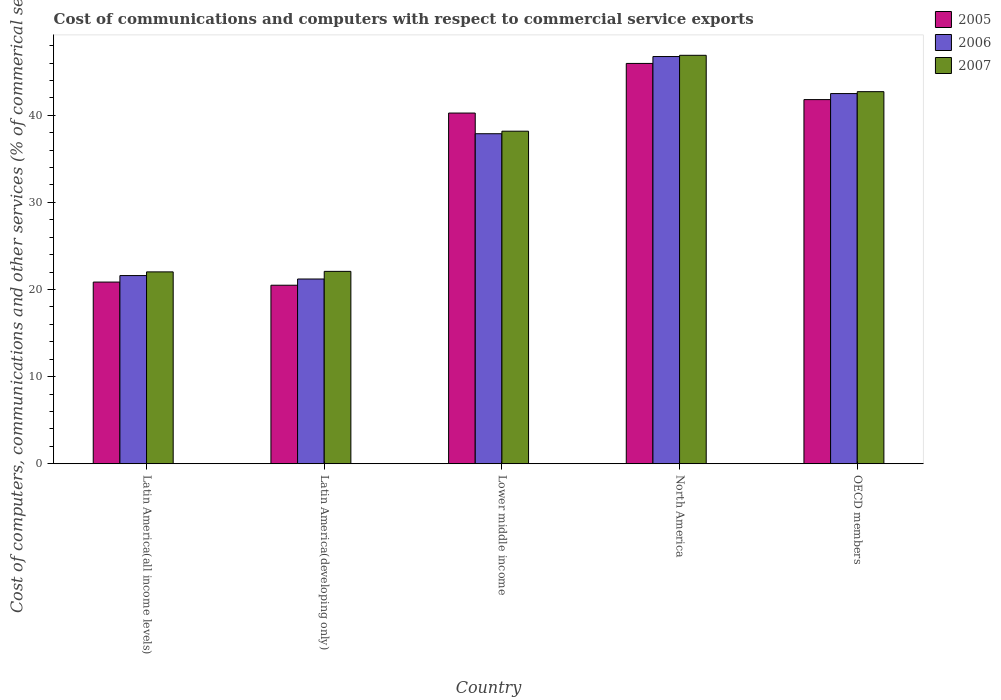How many bars are there on the 2nd tick from the left?
Your answer should be compact. 3. How many bars are there on the 5th tick from the right?
Make the answer very short. 3. What is the label of the 2nd group of bars from the left?
Your response must be concise. Latin America(developing only). What is the cost of communications and computers in 2005 in Latin America(developing only)?
Your answer should be very brief. 20.49. Across all countries, what is the maximum cost of communications and computers in 2006?
Your response must be concise. 46.75. Across all countries, what is the minimum cost of communications and computers in 2005?
Provide a short and direct response. 20.49. In which country was the cost of communications and computers in 2006 minimum?
Offer a terse response. Latin America(developing only). What is the total cost of communications and computers in 2007 in the graph?
Your response must be concise. 171.89. What is the difference between the cost of communications and computers in 2005 in Latin America(all income levels) and that in OECD members?
Keep it short and to the point. -20.95. What is the difference between the cost of communications and computers in 2007 in North America and the cost of communications and computers in 2006 in OECD members?
Give a very brief answer. 4.39. What is the average cost of communications and computers in 2006 per country?
Provide a short and direct response. 33.99. What is the difference between the cost of communications and computers of/in 2005 and cost of communications and computers of/in 2007 in Latin America(all income levels)?
Give a very brief answer. -1.17. What is the ratio of the cost of communications and computers in 2005 in Latin America(all income levels) to that in North America?
Your answer should be very brief. 0.45. Is the cost of communications and computers in 2007 in Latin America(developing only) less than that in OECD members?
Provide a short and direct response. Yes. What is the difference between the highest and the second highest cost of communications and computers in 2006?
Make the answer very short. 4.61. What is the difference between the highest and the lowest cost of communications and computers in 2005?
Your answer should be compact. 25.46. Is the sum of the cost of communications and computers in 2005 in Lower middle income and North America greater than the maximum cost of communications and computers in 2007 across all countries?
Offer a very short reply. Yes. What does the 1st bar from the right in OECD members represents?
Your answer should be compact. 2007. How many bars are there?
Provide a succinct answer. 15. Does the graph contain any zero values?
Offer a terse response. No. Where does the legend appear in the graph?
Ensure brevity in your answer.  Top right. How many legend labels are there?
Your response must be concise. 3. What is the title of the graph?
Offer a terse response. Cost of communications and computers with respect to commercial service exports. Does "1994" appear as one of the legend labels in the graph?
Your answer should be compact. No. What is the label or title of the Y-axis?
Provide a succinct answer. Cost of computers, communications and other services (% of commerical service exports). What is the Cost of computers, communications and other services (% of commerical service exports) of 2005 in Latin America(all income levels)?
Ensure brevity in your answer.  20.86. What is the Cost of computers, communications and other services (% of commerical service exports) of 2006 in Latin America(all income levels)?
Your answer should be compact. 21.6. What is the Cost of computers, communications and other services (% of commerical service exports) of 2007 in Latin America(all income levels)?
Your answer should be compact. 22.02. What is the Cost of computers, communications and other services (% of commerical service exports) in 2005 in Latin America(developing only)?
Give a very brief answer. 20.49. What is the Cost of computers, communications and other services (% of commerical service exports) of 2006 in Latin America(developing only)?
Your answer should be compact. 21.21. What is the Cost of computers, communications and other services (% of commerical service exports) of 2007 in Latin America(developing only)?
Keep it short and to the point. 22.09. What is the Cost of computers, communications and other services (% of commerical service exports) in 2005 in Lower middle income?
Keep it short and to the point. 40.26. What is the Cost of computers, communications and other services (% of commerical service exports) in 2006 in Lower middle income?
Provide a succinct answer. 37.89. What is the Cost of computers, communications and other services (% of commerical service exports) in 2007 in Lower middle income?
Provide a short and direct response. 38.18. What is the Cost of computers, communications and other services (% of commerical service exports) in 2005 in North America?
Make the answer very short. 45.96. What is the Cost of computers, communications and other services (% of commerical service exports) in 2006 in North America?
Your response must be concise. 46.75. What is the Cost of computers, communications and other services (% of commerical service exports) of 2007 in North America?
Provide a short and direct response. 46.89. What is the Cost of computers, communications and other services (% of commerical service exports) of 2005 in OECD members?
Give a very brief answer. 41.8. What is the Cost of computers, communications and other services (% of commerical service exports) in 2006 in OECD members?
Give a very brief answer. 42.5. What is the Cost of computers, communications and other services (% of commerical service exports) in 2007 in OECD members?
Your answer should be very brief. 42.72. Across all countries, what is the maximum Cost of computers, communications and other services (% of commerical service exports) of 2005?
Give a very brief answer. 45.96. Across all countries, what is the maximum Cost of computers, communications and other services (% of commerical service exports) in 2006?
Your response must be concise. 46.75. Across all countries, what is the maximum Cost of computers, communications and other services (% of commerical service exports) of 2007?
Make the answer very short. 46.89. Across all countries, what is the minimum Cost of computers, communications and other services (% of commerical service exports) in 2005?
Your answer should be compact. 20.49. Across all countries, what is the minimum Cost of computers, communications and other services (% of commerical service exports) in 2006?
Your response must be concise. 21.21. Across all countries, what is the minimum Cost of computers, communications and other services (% of commerical service exports) in 2007?
Your answer should be compact. 22.02. What is the total Cost of computers, communications and other services (% of commerical service exports) in 2005 in the graph?
Give a very brief answer. 169.37. What is the total Cost of computers, communications and other services (% of commerical service exports) of 2006 in the graph?
Your response must be concise. 169.94. What is the total Cost of computers, communications and other services (% of commerical service exports) of 2007 in the graph?
Provide a succinct answer. 171.89. What is the difference between the Cost of computers, communications and other services (% of commerical service exports) in 2005 in Latin America(all income levels) and that in Latin America(developing only)?
Give a very brief answer. 0.36. What is the difference between the Cost of computers, communications and other services (% of commerical service exports) of 2006 in Latin America(all income levels) and that in Latin America(developing only)?
Keep it short and to the point. 0.4. What is the difference between the Cost of computers, communications and other services (% of commerical service exports) in 2007 in Latin America(all income levels) and that in Latin America(developing only)?
Offer a very short reply. -0.06. What is the difference between the Cost of computers, communications and other services (% of commerical service exports) of 2005 in Latin America(all income levels) and that in Lower middle income?
Your answer should be compact. -19.4. What is the difference between the Cost of computers, communications and other services (% of commerical service exports) in 2006 in Latin America(all income levels) and that in Lower middle income?
Offer a terse response. -16.28. What is the difference between the Cost of computers, communications and other services (% of commerical service exports) of 2007 in Latin America(all income levels) and that in Lower middle income?
Provide a succinct answer. -16.15. What is the difference between the Cost of computers, communications and other services (% of commerical service exports) of 2005 in Latin America(all income levels) and that in North America?
Provide a succinct answer. -25.1. What is the difference between the Cost of computers, communications and other services (% of commerical service exports) in 2006 in Latin America(all income levels) and that in North America?
Your answer should be compact. -25.14. What is the difference between the Cost of computers, communications and other services (% of commerical service exports) in 2007 in Latin America(all income levels) and that in North America?
Offer a very short reply. -24.87. What is the difference between the Cost of computers, communications and other services (% of commerical service exports) of 2005 in Latin America(all income levels) and that in OECD members?
Provide a succinct answer. -20.95. What is the difference between the Cost of computers, communications and other services (% of commerical service exports) in 2006 in Latin America(all income levels) and that in OECD members?
Your response must be concise. -20.89. What is the difference between the Cost of computers, communications and other services (% of commerical service exports) in 2007 in Latin America(all income levels) and that in OECD members?
Offer a very short reply. -20.69. What is the difference between the Cost of computers, communications and other services (% of commerical service exports) in 2005 in Latin America(developing only) and that in Lower middle income?
Offer a terse response. -19.76. What is the difference between the Cost of computers, communications and other services (% of commerical service exports) in 2006 in Latin America(developing only) and that in Lower middle income?
Make the answer very short. -16.68. What is the difference between the Cost of computers, communications and other services (% of commerical service exports) of 2007 in Latin America(developing only) and that in Lower middle income?
Your answer should be compact. -16.09. What is the difference between the Cost of computers, communications and other services (% of commerical service exports) in 2005 in Latin America(developing only) and that in North America?
Your answer should be compact. -25.46. What is the difference between the Cost of computers, communications and other services (% of commerical service exports) of 2006 in Latin America(developing only) and that in North America?
Ensure brevity in your answer.  -25.54. What is the difference between the Cost of computers, communications and other services (% of commerical service exports) of 2007 in Latin America(developing only) and that in North America?
Keep it short and to the point. -24.8. What is the difference between the Cost of computers, communications and other services (% of commerical service exports) of 2005 in Latin America(developing only) and that in OECD members?
Offer a very short reply. -21.31. What is the difference between the Cost of computers, communications and other services (% of commerical service exports) in 2006 in Latin America(developing only) and that in OECD members?
Offer a very short reply. -21.29. What is the difference between the Cost of computers, communications and other services (% of commerical service exports) in 2007 in Latin America(developing only) and that in OECD members?
Provide a succinct answer. -20.63. What is the difference between the Cost of computers, communications and other services (% of commerical service exports) in 2005 in Lower middle income and that in North America?
Provide a short and direct response. -5.7. What is the difference between the Cost of computers, communications and other services (% of commerical service exports) of 2006 in Lower middle income and that in North America?
Provide a succinct answer. -8.86. What is the difference between the Cost of computers, communications and other services (% of commerical service exports) of 2007 in Lower middle income and that in North America?
Your answer should be compact. -8.71. What is the difference between the Cost of computers, communications and other services (% of commerical service exports) in 2005 in Lower middle income and that in OECD members?
Your answer should be compact. -1.54. What is the difference between the Cost of computers, communications and other services (% of commerical service exports) in 2006 in Lower middle income and that in OECD members?
Make the answer very short. -4.61. What is the difference between the Cost of computers, communications and other services (% of commerical service exports) in 2007 in Lower middle income and that in OECD members?
Ensure brevity in your answer.  -4.54. What is the difference between the Cost of computers, communications and other services (% of commerical service exports) of 2005 in North America and that in OECD members?
Your answer should be compact. 4.15. What is the difference between the Cost of computers, communications and other services (% of commerical service exports) of 2006 in North America and that in OECD members?
Offer a very short reply. 4.25. What is the difference between the Cost of computers, communications and other services (% of commerical service exports) in 2007 in North America and that in OECD members?
Your answer should be very brief. 4.17. What is the difference between the Cost of computers, communications and other services (% of commerical service exports) of 2005 in Latin America(all income levels) and the Cost of computers, communications and other services (% of commerical service exports) of 2006 in Latin America(developing only)?
Give a very brief answer. -0.35. What is the difference between the Cost of computers, communications and other services (% of commerical service exports) in 2005 in Latin America(all income levels) and the Cost of computers, communications and other services (% of commerical service exports) in 2007 in Latin America(developing only)?
Offer a very short reply. -1.23. What is the difference between the Cost of computers, communications and other services (% of commerical service exports) in 2006 in Latin America(all income levels) and the Cost of computers, communications and other services (% of commerical service exports) in 2007 in Latin America(developing only)?
Keep it short and to the point. -0.48. What is the difference between the Cost of computers, communications and other services (% of commerical service exports) in 2005 in Latin America(all income levels) and the Cost of computers, communications and other services (% of commerical service exports) in 2006 in Lower middle income?
Provide a succinct answer. -17.03. What is the difference between the Cost of computers, communications and other services (% of commerical service exports) of 2005 in Latin America(all income levels) and the Cost of computers, communications and other services (% of commerical service exports) of 2007 in Lower middle income?
Your answer should be very brief. -17.32. What is the difference between the Cost of computers, communications and other services (% of commerical service exports) in 2006 in Latin America(all income levels) and the Cost of computers, communications and other services (% of commerical service exports) in 2007 in Lower middle income?
Offer a very short reply. -16.57. What is the difference between the Cost of computers, communications and other services (% of commerical service exports) in 2005 in Latin America(all income levels) and the Cost of computers, communications and other services (% of commerical service exports) in 2006 in North America?
Your answer should be very brief. -25.89. What is the difference between the Cost of computers, communications and other services (% of commerical service exports) in 2005 in Latin America(all income levels) and the Cost of computers, communications and other services (% of commerical service exports) in 2007 in North America?
Make the answer very short. -26.03. What is the difference between the Cost of computers, communications and other services (% of commerical service exports) of 2006 in Latin America(all income levels) and the Cost of computers, communications and other services (% of commerical service exports) of 2007 in North America?
Ensure brevity in your answer.  -25.29. What is the difference between the Cost of computers, communications and other services (% of commerical service exports) of 2005 in Latin America(all income levels) and the Cost of computers, communications and other services (% of commerical service exports) of 2006 in OECD members?
Provide a short and direct response. -21.64. What is the difference between the Cost of computers, communications and other services (% of commerical service exports) in 2005 in Latin America(all income levels) and the Cost of computers, communications and other services (% of commerical service exports) in 2007 in OECD members?
Your answer should be very brief. -21.86. What is the difference between the Cost of computers, communications and other services (% of commerical service exports) in 2006 in Latin America(all income levels) and the Cost of computers, communications and other services (% of commerical service exports) in 2007 in OECD members?
Ensure brevity in your answer.  -21.11. What is the difference between the Cost of computers, communications and other services (% of commerical service exports) in 2005 in Latin America(developing only) and the Cost of computers, communications and other services (% of commerical service exports) in 2006 in Lower middle income?
Offer a very short reply. -17.39. What is the difference between the Cost of computers, communications and other services (% of commerical service exports) in 2005 in Latin America(developing only) and the Cost of computers, communications and other services (% of commerical service exports) in 2007 in Lower middle income?
Offer a terse response. -17.68. What is the difference between the Cost of computers, communications and other services (% of commerical service exports) of 2006 in Latin America(developing only) and the Cost of computers, communications and other services (% of commerical service exports) of 2007 in Lower middle income?
Offer a very short reply. -16.97. What is the difference between the Cost of computers, communications and other services (% of commerical service exports) of 2005 in Latin America(developing only) and the Cost of computers, communications and other services (% of commerical service exports) of 2006 in North America?
Give a very brief answer. -26.25. What is the difference between the Cost of computers, communications and other services (% of commerical service exports) in 2005 in Latin America(developing only) and the Cost of computers, communications and other services (% of commerical service exports) in 2007 in North America?
Provide a succinct answer. -26.4. What is the difference between the Cost of computers, communications and other services (% of commerical service exports) in 2006 in Latin America(developing only) and the Cost of computers, communications and other services (% of commerical service exports) in 2007 in North America?
Ensure brevity in your answer.  -25.68. What is the difference between the Cost of computers, communications and other services (% of commerical service exports) in 2005 in Latin America(developing only) and the Cost of computers, communications and other services (% of commerical service exports) in 2006 in OECD members?
Offer a terse response. -22. What is the difference between the Cost of computers, communications and other services (% of commerical service exports) in 2005 in Latin America(developing only) and the Cost of computers, communications and other services (% of commerical service exports) in 2007 in OECD members?
Give a very brief answer. -22.22. What is the difference between the Cost of computers, communications and other services (% of commerical service exports) in 2006 in Latin America(developing only) and the Cost of computers, communications and other services (% of commerical service exports) in 2007 in OECD members?
Make the answer very short. -21.51. What is the difference between the Cost of computers, communications and other services (% of commerical service exports) in 2005 in Lower middle income and the Cost of computers, communications and other services (% of commerical service exports) in 2006 in North America?
Give a very brief answer. -6.49. What is the difference between the Cost of computers, communications and other services (% of commerical service exports) in 2005 in Lower middle income and the Cost of computers, communications and other services (% of commerical service exports) in 2007 in North America?
Your answer should be very brief. -6.63. What is the difference between the Cost of computers, communications and other services (% of commerical service exports) in 2006 in Lower middle income and the Cost of computers, communications and other services (% of commerical service exports) in 2007 in North America?
Offer a terse response. -9. What is the difference between the Cost of computers, communications and other services (% of commerical service exports) in 2005 in Lower middle income and the Cost of computers, communications and other services (% of commerical service exports) in 2006 in OECD members?
Your answer should be very brief. -2.24. What is the difference between the Cost of computers, communications and other services (% of commerical service exports) in 2005 in Lower middle income and the Cost of computers, communications and other services (% of commerical service exports) in 2007 in OECD members?
Provide a short and direct response. -2.46. What is the difference between the Cost of computers, communications and other services (% of commerical service exports) of 2006 in Lower middle income and the Cost of computers, communications and other services (% of commerical service exports) of 2007 in OECD members?
Provide a succinct answer. -4.83. What is the difference between the Cost of computers, communications and other services (% of commerical service exports) in 2005 in North America and the Cost of computers, communications and other services (% of commerical service exports) in 2006 in OECD members?
Provide a short and direct response. 3.46. What is the difference between the Cost of computers, communications and other services (% of commerical service exports) of 2005 in North America and the Cost of computers, communications and other services (% of commerical service exports) of 2007 in OECD members?
Provide a short and direct response. 3.24. What is the difference between the Cost of computers, communications and other services (% of commerical service exports) in 2006 in North America and the Cost of computers, communications and other services (% of commerical service exports) in 2007 in OECD members?
Your response must be concise. 4.03. What is the average Cost of computers, communications and other services (% of commerical service exports) of 2005 per country?
Your answer should be very brief. 33.87. What is the average Cost of computers, communications and other services (% of commerical service exports) of 2006 per country?
Ensure brevity in your answer.  33.99. What is the average Cost of computers, communications and other services (% of commerical service exports) in 2007 per country?
Provide a short and direct response. 34.38. What is the difference between the Cost of computers, communications and other services (% of commerical service exports) in 2005 and Cost of computers, communications and other services (% of commerical service exports) in 2006 in Latin America(all income levels)?
Make the answer very short. -0.75. What is the difference between the Cost of computers, communications and other services (% of commerical service exports) of 2005 and Cost of computers, communications and other services (% of commerical service exports) of 2007 in Latin America(all income levels)?
Your answer should be compact. -1.17. What is the difference between the Cost of computers, communications and other services (% of commerical service exports) in 2006 and Cost of computers, communications and other services (% of commerical service exports) in 2007 in Latin America(all income levels)?
Ensure brevity in your answer.  -0.42. What is the difference between the Cost of computers, communications and other services (% of commerical service exports) of 2005 and Cost of computers, communications and other services (% of commerical service exports) of 2006 in Latin America(developing only)?
Keep it short and to the point. -0.71. What is the difference between the Cost of computers, communications and other services (% of commerical service exports) in 2005 and Cost of computers, communications and other services (% of commerical service exports) in 2007 in Latin America(developing only)?
Your response must be concise. -1.59. What is the difference between the Cost of computers, communications and other services (% of commerical service exports) in 2006 and Cost of computers, communications and other services (% of commerical service exports) in 2007 in Latin America(developing only)?
Offer a terse response. -0.88. What is the difference between the Cost of computers, communications and other services (% of commerical service exports) of 2005 and Cost of computers, communications and other services (% of commerical service exports) of 2006 in Lower middle income?
Keep it short and to the point. 2.37. What is the difference between the Cost of computers, communications and other services (% of commerical service exports) of 2005 and Cost of computers, communications and other services (% of commerical service exports) of 2007 in Lower middle income?
Make the answer very short. 2.08. What is the difference between the Cost of computers, communications and other services (% of commerical service exports) of 2006 and Cost of computers, communications and other services (% of commerical service exports) of 2007 in Lower middle income?
Give a very brief answer. -0.29. What is the difference between the Cost of computers, communications and other services (% of commerical service exports) of 2005 and Cost of computers, communications and other services (% of commerical service exports) of 2006 in North America?
Provide a short and direct response. -0.79. What is the difference between the Cost of computers, communications and other services (% of commerical service exports) in 2005 and Cost of computers, communications and other services (% of commerical service exports) in 2007 in North America?
Your response must be concise. -0.93. What is the difference between the Cost of computers, communications and other services (% of commerical service exports) of 2006 and Cost of computers, communications and other services (% of commerical service exports) of 2007 in North America?
Provide a short and direct response. -0.14. What is the difference between the Cost of computers, communications and other services (% of commerical service exports) of 2005 and Cost of computers, communications and other services (% of commerical service exports) of 2006 in OECD members?
Offer a very short reply. -0.69. What is the difference between the Cost of computers, communications and other services (% of commerical service exports) of 2005 and Cost of computers, communications and other services (% of commerical service exports) of 2007 in OECD members?
Keep it short and to the point. -0.91. What is the difference between the Cost of computers, communications and other services (% of commerical service exports) in 2006 and Cost of computers, communications and other services (% of commerical service exports) in 2007 in OECD members?
Ensure brevity in your answer.  -0.22. What is the ratio of the Cost of computers, communications and other services (% of commerical service exports) in 2005 in Latin America(all income levels) to that in Latin America(developing only)?
Provide a short and direct response. 1.02. What is the ratio of the Cost of computers, communications and other services (% of commerical service exports) of 2006 in Latin America(all income levels) to that in Latin America(developing only)?
Offer a terse response. 1.02. What is the ratio of the Cost of computers, communications and other services (% of commerical service exports) of 2005 in Latin America(all income levels) to that in Lower middle income?
Offer a very short reply. 0.52. What is the ratio of the Cost of computers, communications and other services (% of commerical service exports) of 2006 in Latin America(all income levels) to that in Lower middle income?
Provide a short and direct response. 0.57. What is the ratio of the Cost of computers, communications and other services (% of commerical service exports) in 2007 in Latin America(all income levels) to that in Lower middle income?
Give a very brief answer. 0.58. What is the ratio of the Cost of computers, communications and other services (% of commerical service exports) in 2005 in Latin America(all income levels) to that in North America?
Provide a short and direct response. 0.45. What is the ratio of the Cost of computers, communications and other services (% of commerical service exports) of 2006 in Latin America(all income levels) to that in North America?
Provide a succinct answer. 0.46. What is the ratio of the Cost of computers, communications and other services (% of commerical service exports) of 2007 in Latin America(all income levels) to that in North America?
Provide a short and direct response. 0.47. What is the ratio of the Cost of computers, communications and other services (% of commerical service exports) of 2005 in Latin America(all income levels) to that in OECD members?
Make the answer very short. 0.5. What is the ratio of the Cost of computers, communications and other services (% of commerical service exports) in 2006 in Latin America(all income levels) to that in OECD members?
Your answer should be compact. 0.51. What is the ratio of the Cost of computers, communications and other services (% of commerical service exports) in 2007 in Latin America(all income levels) to that in OECD members?
Offer a very short reply. 0.52. What is the ratio of the Cost of computers, communications and other services (% of commerical service exports) of 2005 in Latin America(developing only) to that in Lower middle income?
Provide a succinct answer. 0.51. What is the ratio of the Cost of computers, communications and other services (% of commerical service exports) in 2006 in Latin America(developing only) to that in Lower middle income?
Give a very brief answer. 0.56. What is the ratio of the Cost of computers, communications and other services (% of commerical service exports) in 2007 in Latin America(developing only) to that in Lower middle income?
Offer a terse response. 0.58. What is the ratio of the Cost of computers, communications and other services (% of commerical service exports) in 2005 in Latin America(developing only) to that in North America?
Make the answer very short. 0.45. What is the ratio of the Cost of computers, communications and other services (% of commerical service exports) in 2006 in Latin America(developing only) to that in North America?
Make the answer very short. 0.45. What is the ratio of the Cost of computers, communications and other services (% of commerical service exports) of 2007 in Latin America(developing only) to that in North America?
Make the answer very short. 0.47. What is the ratio of the Cost of computers, communications and other services (% of commerical service exports) in 2005 in Latin America(developing only) to that in OECD members?
Make the answer very short. 0.49. What is the ratio of the Cost of computers, communications and other services (% of commerical service exports) in 2006 in Latin America(developing only) to that in OECD members?
Make the answer very short. 0.5. What is the ratio of the Cost of computers, communications and other services (% of commerical service exports) of 2007 in Latin America(developing only) to that in OECD members?
Offer a terse response. 0.52. What is the ratio of the Cost of computers, communications and other services (% of commerical service exports) of 2005 in Lower middle income to that in North America?
Ensure brevity in your answer.  0.88. What is the ratio of the Cost of computers, communications and other services (% of commerical service exports) in 2006 in Lower middle income to that in North America?
Give a very brief answer. 0.81. What is the ratio of the Cost of computers, communications and other services (% of commerical service exports) of 2007 in Lower middle income to that in North America?
Give a very brief answer. 0.81. What is the ratio of the Cost of computers, communications and other services (% of commerical service exports) of 2005 in Lower middle income to that in OECD members?
Your response must be concise. 0.96. What is the ratio of the Cost of computers, communications and other services (% of commerical service exports) of 2006 in Lower middle income to that in OECD members?
Provide a succinct answer. 0.89. What is the ratio of the Cost of computers, communications and other services (% of commerical service exports) of 2007 in Lower middle income to that in OECD members?
Provide a succinct answer. 0.89. What is the ratio of the Cost of computers, communications and other services (% of commerical service exports) in 2005 in North America to that in OECD members?
Give a very brief answer. 1.1. What is the ratio of the Cost of computers, communications and other services (% of commerical service exports) of 2006 in North America to that in OECD members?
Give a very brief answer. 1.1. What is the ratio of the Cost of computers, communications and other services (% of commerical service exports) of 2007 in North America to that in OECD members?
Provide a short and direct response. 1.1. What is the difference between the highest and the second highest Cost of computers, communications and other services (% of commerical service exports) in 2005?
Your response must be concise. 4.15. What is the difference between the highest and the second highest Cost of computers, communications and other services (% of commerical service exports) of 2006?
Give a very brief answer. 4.25. What is the difference between the highest and the second highest Cost of computers, communications and other services (% of commerical service exports) in 2007?
Your answer should be very brief. 4.17. What is the difference between the highest and the lowest Cost of computers, communications and other services (% of commerical service exports) in 2005?
Make the answer very short. 25.46. What is the difference between the highest and the lowest Cost of computers, communications and other services (% of commerical service exports) of 2006?
Your response must be concise. 25.54. What is the difference between the highest and the lowest Cost of computers, communications and other services (% of commerical service exports) of 2007?
Your response must be concise. 24.87. 